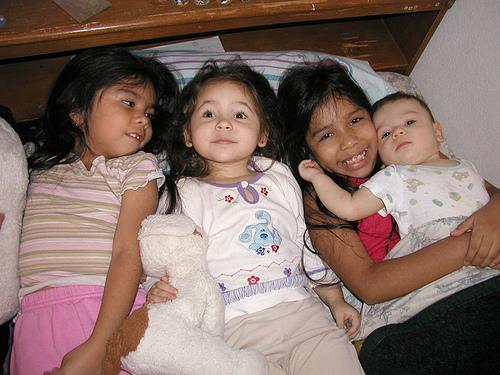How many children are laying in the bed?
Quick response, please. 4. How many children are smiling?
Concise answer only. 2. What type of material is the bed made out of?
Answer briefly. Wood. 